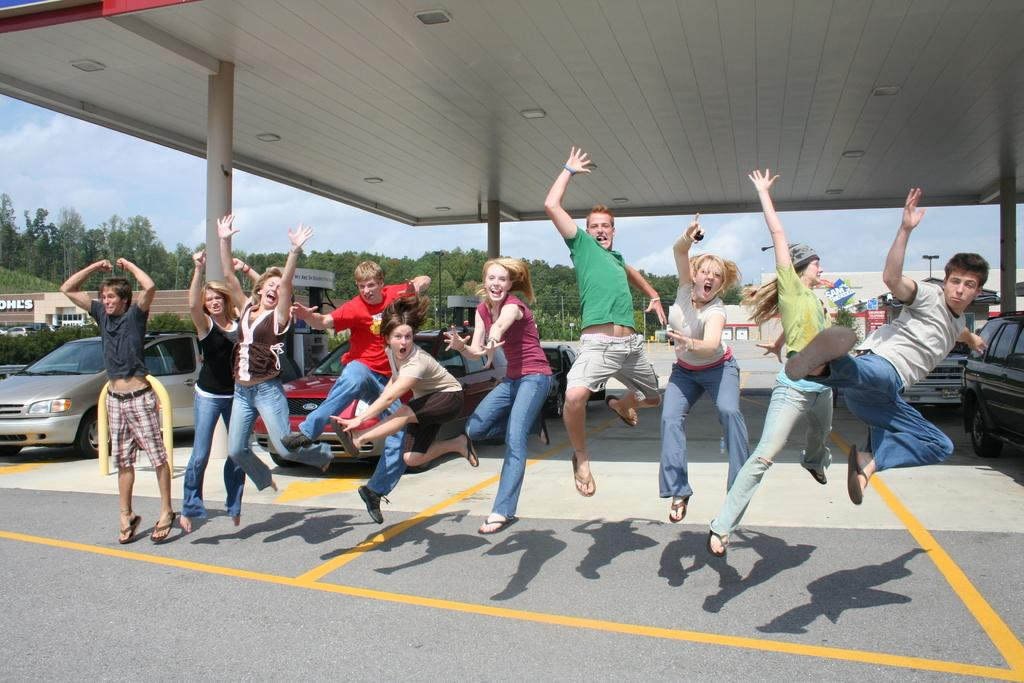What are the people in the image doing? The people in the image are jumping. What can be seen on the ground beneath the people? The shadows of the people are visible on the road. What is visible in the background of the image? Trees, cars, poles, boards, and the sky are visible in the background of the image. What color are the trousers worn by the people in the image? There is no information about the color of the people's trousers in the image. Can you see the people's lips in the image? There is no information about the people's lips in the image. 